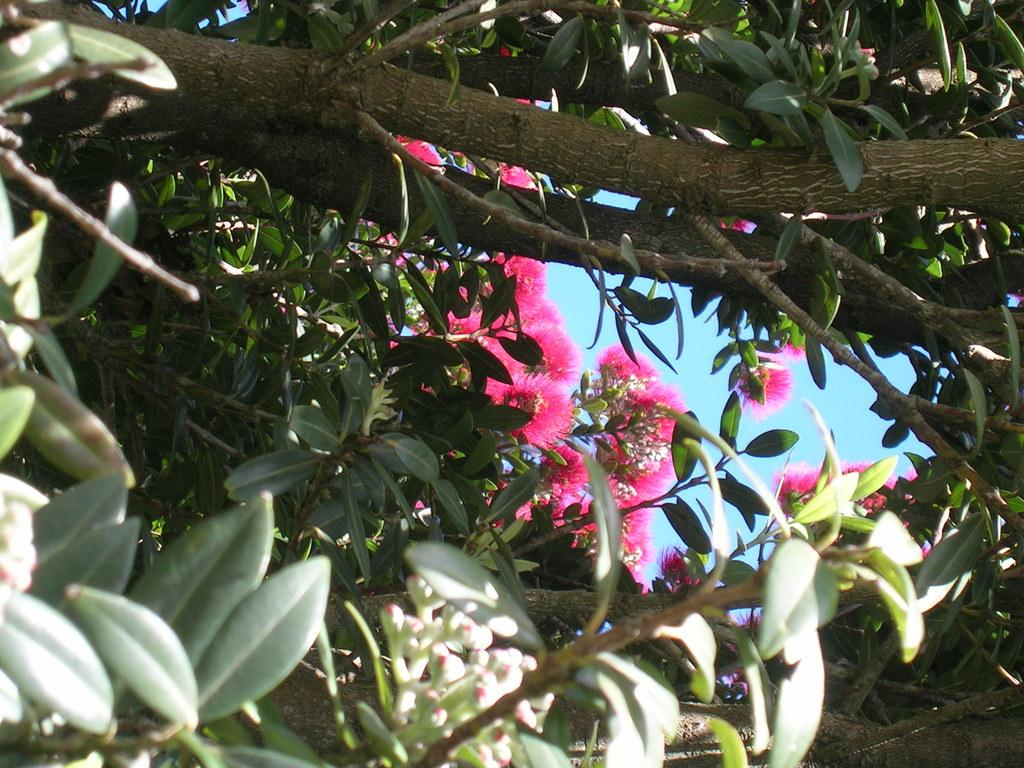What type of vegetation can be seen in the image? There are green leaves and flowers in the image. Can you describe the colors of the flowers? The colors of the flowers are not specified in the facts, but they are visible in the image. What might be the purpose of the green leaves in the image? The green leaves in the image are likely part of a plant or tree, providing photosynthesis and support for the flowers. What type of pencil can be seen in the image? There is no pencil present in the image. What is the weather like in the image? The facts provided do not mention the weather, so it cannot be determined from the image. 